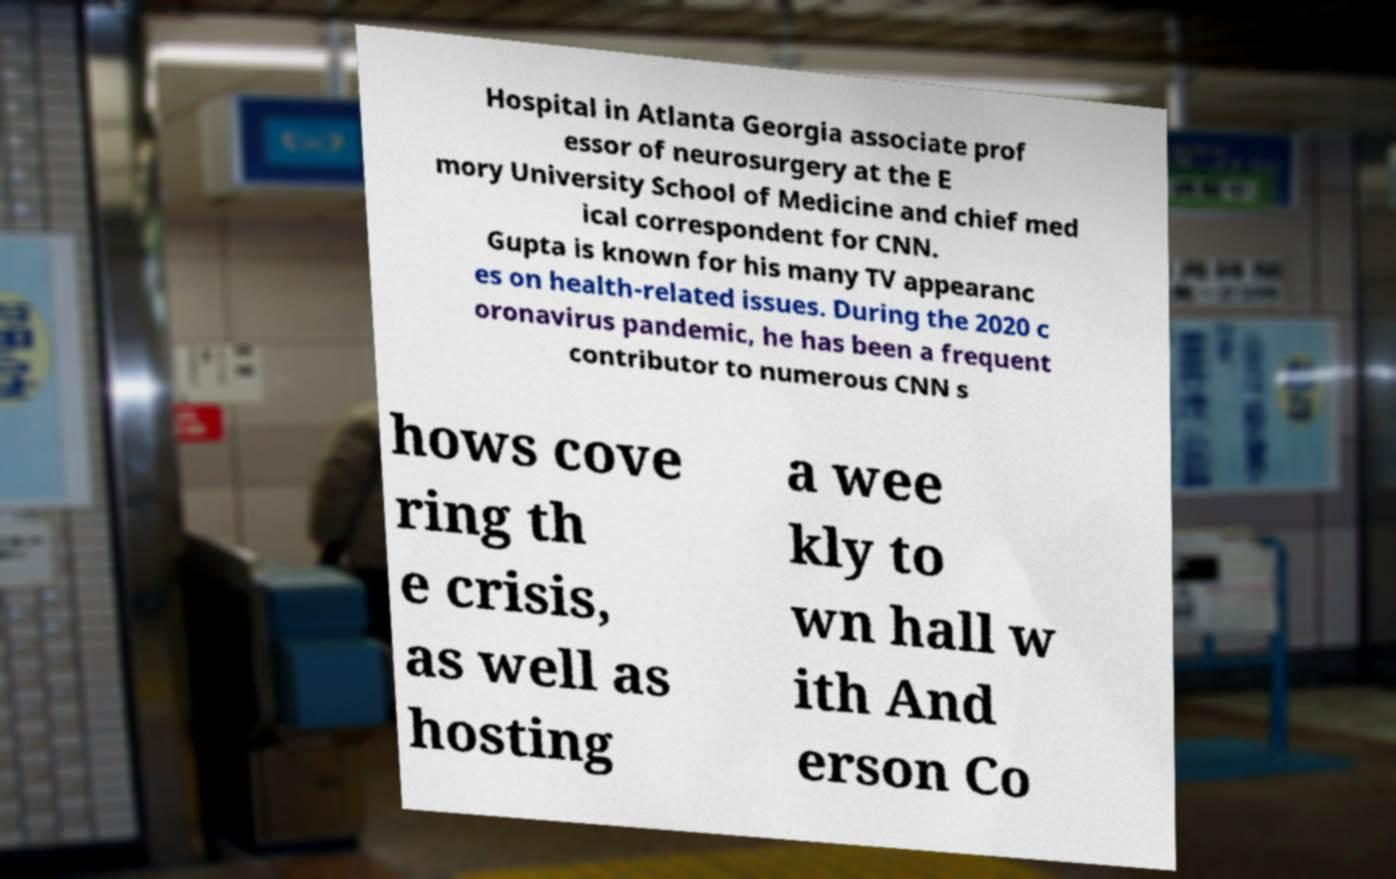Please identify and transcribe the text found in this image. Hospital in Atlanta Georgia associate prof essor of neurosurgery at the E mory University School of Medicine and chief med ical correspondent for CNN. Gupta is known for his many TV appearanc es on health-related issues. During the 2020 c oronavirus pandemic, he has been a frequent contributor to numerous CNN s hows cove ring th e crisis, as well as hosting a wee kly to wn hall w ith And erson Co 